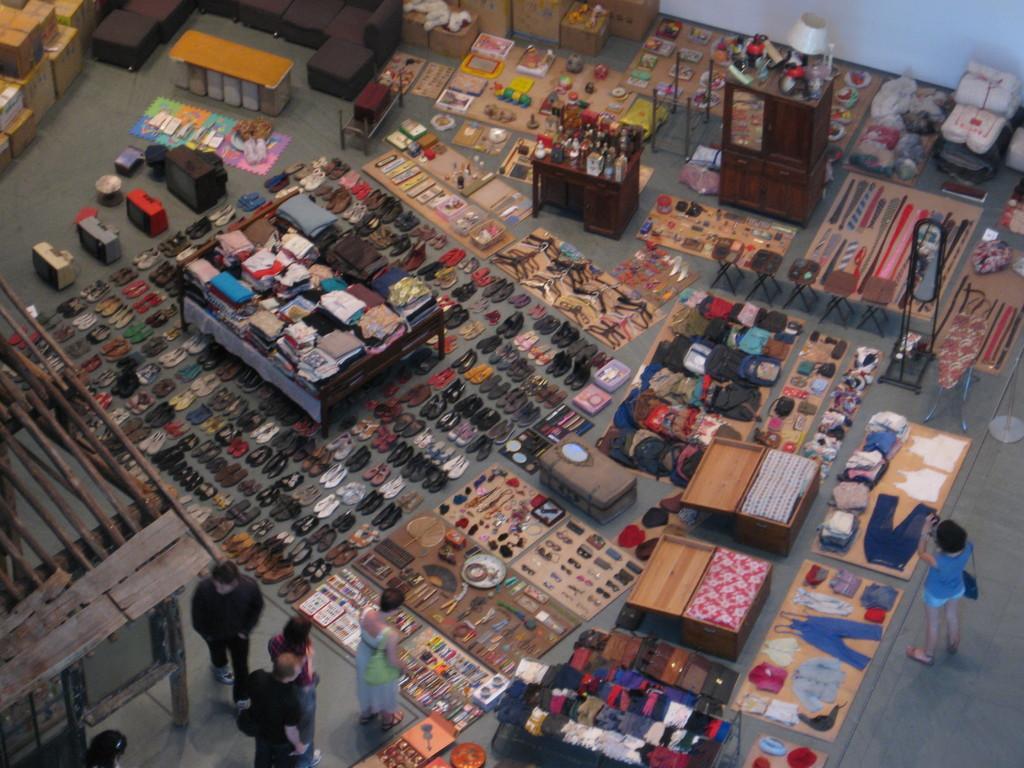Can you describe this image briefly? In the image we can see on the ground people are who are standing there are shoes and sandals and on table there are clothes and there on the table there are scent bottles, perfume bottles. 